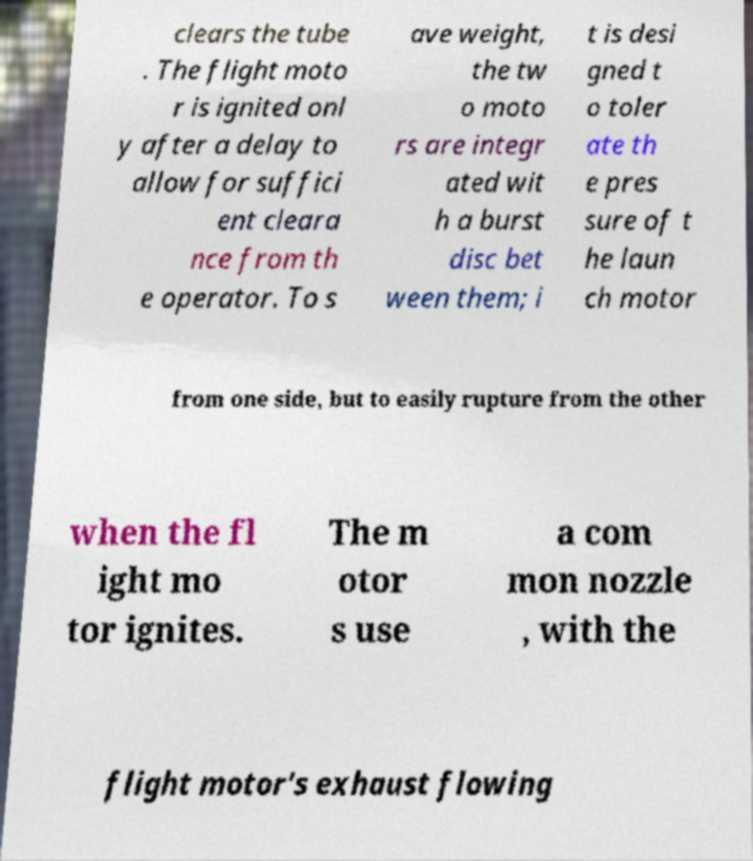Could you extract and type out the text from this image? clears the tube . The flight moto r is ignited onl y after a delay to allow for suffici ent cleara nce from th e operator. To s ave weight, the tw o moto rs are integr ated wit h a burst disc bet ween them; i t is desi gned t o toler ate th e pres sure of t he laun ch motor from one side, but to easily rupture from the other when the fl ight mo tor ignites. The m otor s use a com mon nozzle , with the flight motor's exhaust flowing 